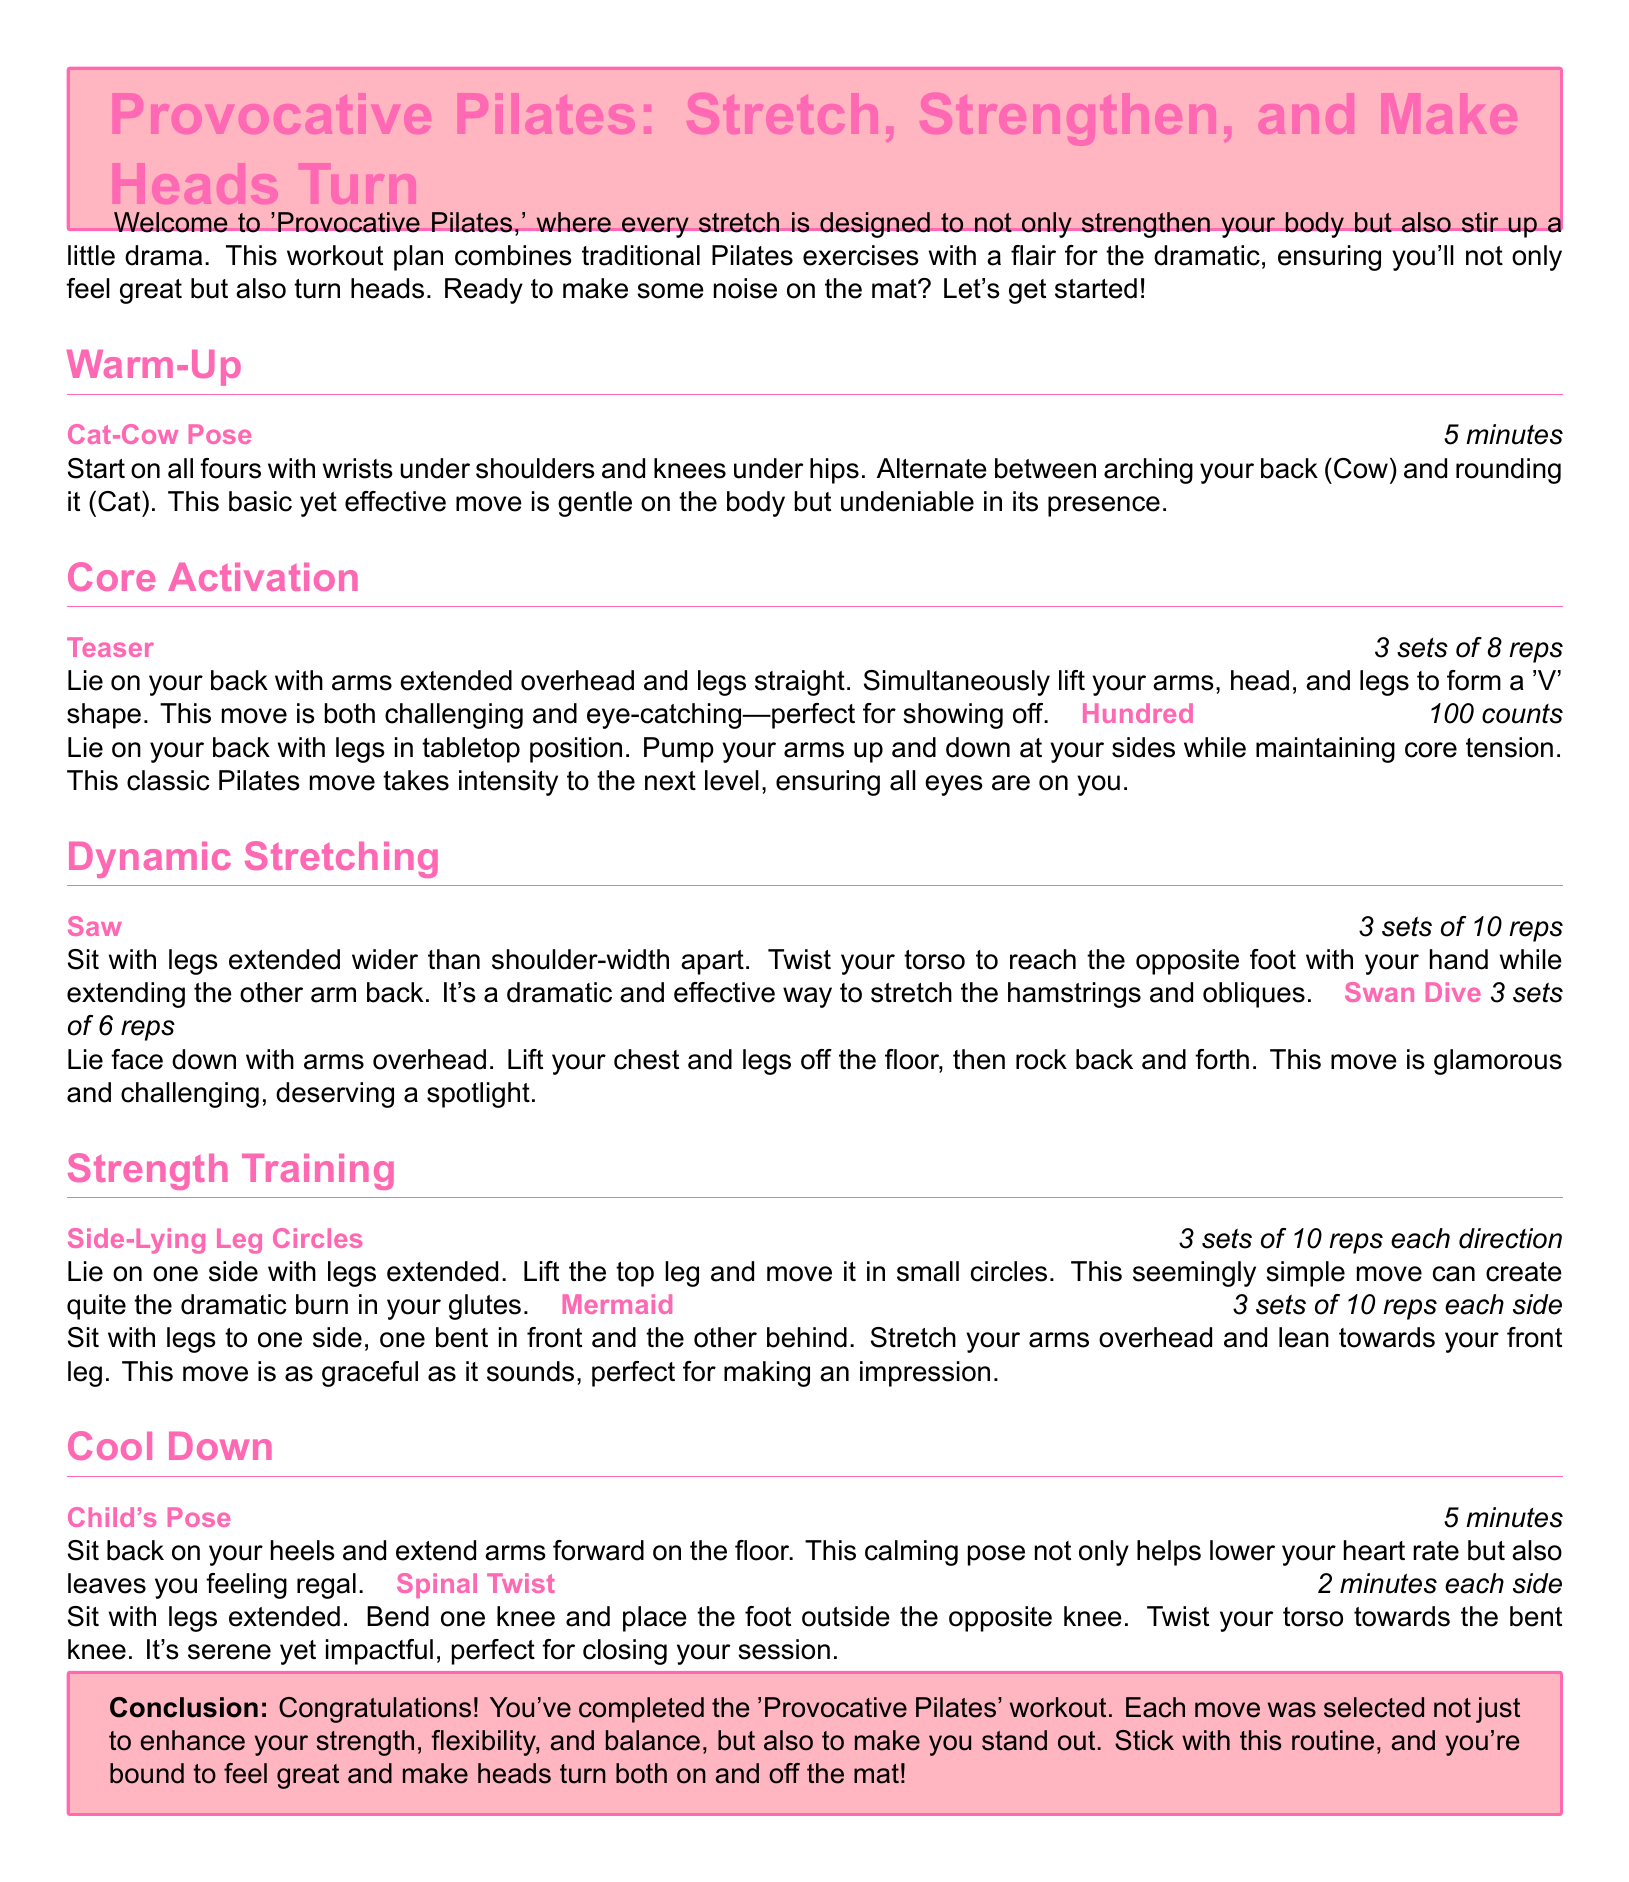What is the title of the workout plan? The title of the workout plan is prominently displayed at the beginning of the document.
Answer: Provocative Pilates: Stretch, Strengthen, and Make Heads Turn How long should you perform the Cat-Cow Pose? The duration for this warm-up exercise is specified in the document.
Answer: 5 minutes How many reps are in the Teaser exercise? The number of repetitions for the Teaser is clearly stated in the plan.
Answer: 3 sets of 8 reps What is the duration for the Child's Pose cool down? This information is mentioned in the cooldown section of the document.
Answer: 5 minutes What type of movements does the Swan Dive involve? The description highlights the nature of the movements performed in this exercise.
Answer: Glamorous and challenging Which body part does the Side-Lying Leg Circles primarily target? The focus area of this exercise is indicated in the document.
Answer: Glutes What kind of flexibility is emphasized in the Mermaid exercise? The document outlines the characteristics of the Mermaid exercise.
Answer: Graceful What type of pose is suggested for the cool down after the workout? The document indicates the type of poses that should be performed during cooldown.
Answer: Calming 